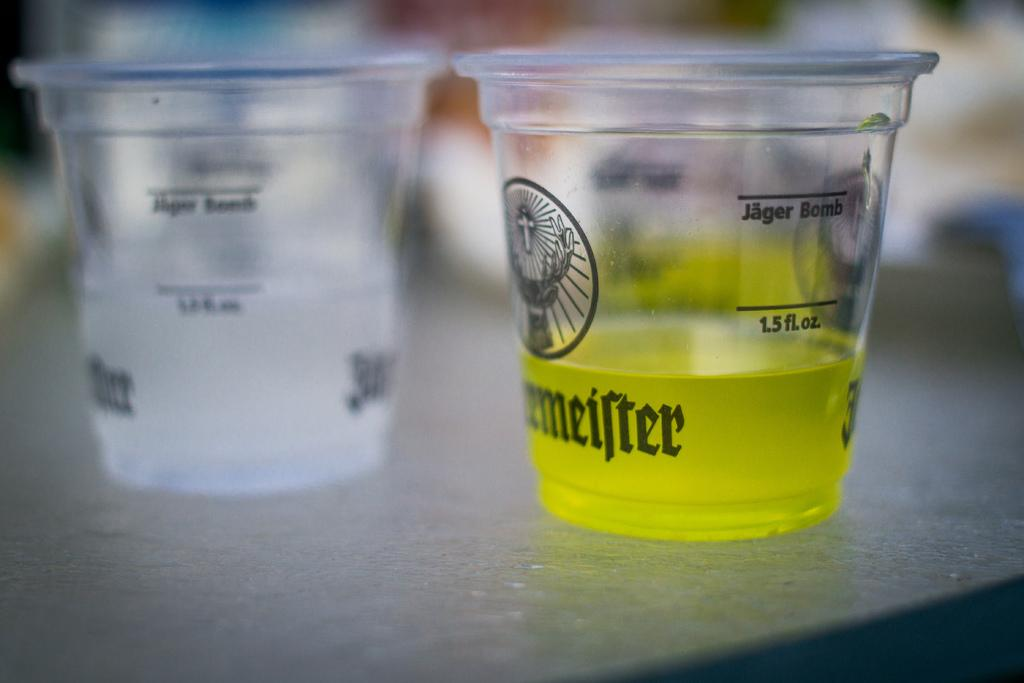<image>
Give a short and clear explanation of the subsequent image. Two plastic Jagermeister cups and one has a yellow liquid in it. 